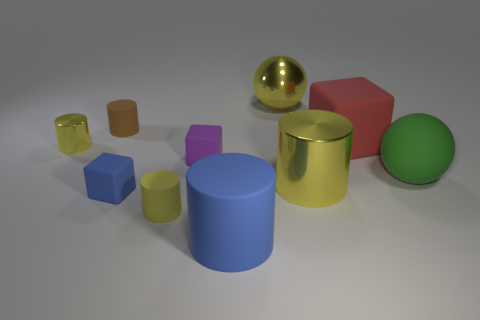There is a ball right of the ball behind the small brown matte thing; what is its material?
Offer a terse response. Rubber. How many large green things have the same shape as the small purple object?
Give a very brief answer. 0. What is the size of the rubber object that is on the right side of the red thing that is behind the big shiny object that is in front of the big green rubber ball?
Ensure brevity in your answer.  Large. What number of cyan things are cubes or large matte cylinders?
Provide a succinct answer. 0. There is a big metallic thing in front of the large metallic sphere; is it the same shape as the red rubber object?
Ensure brevity in your answer.  No. Is the number of yellow metal cylinders in front of the red matte object greater than the number of yellow matte things?
Offer a very short reply. Yes. What number of rubber blocks are the same size as the yellow sphere?
Your response must be concise. 1. What size is the rubber cylinder that is the same color as the metal sphere?
Ensure brevity in your answer.  Small. How many things are either brown metal objects or metallic cylinders behind the green ball?
Keep it short and to the point. 1. What color is the large thing that is both behind the purple block and to the right of the yellow metal sphere?
Your answer should be very brief. Red. 